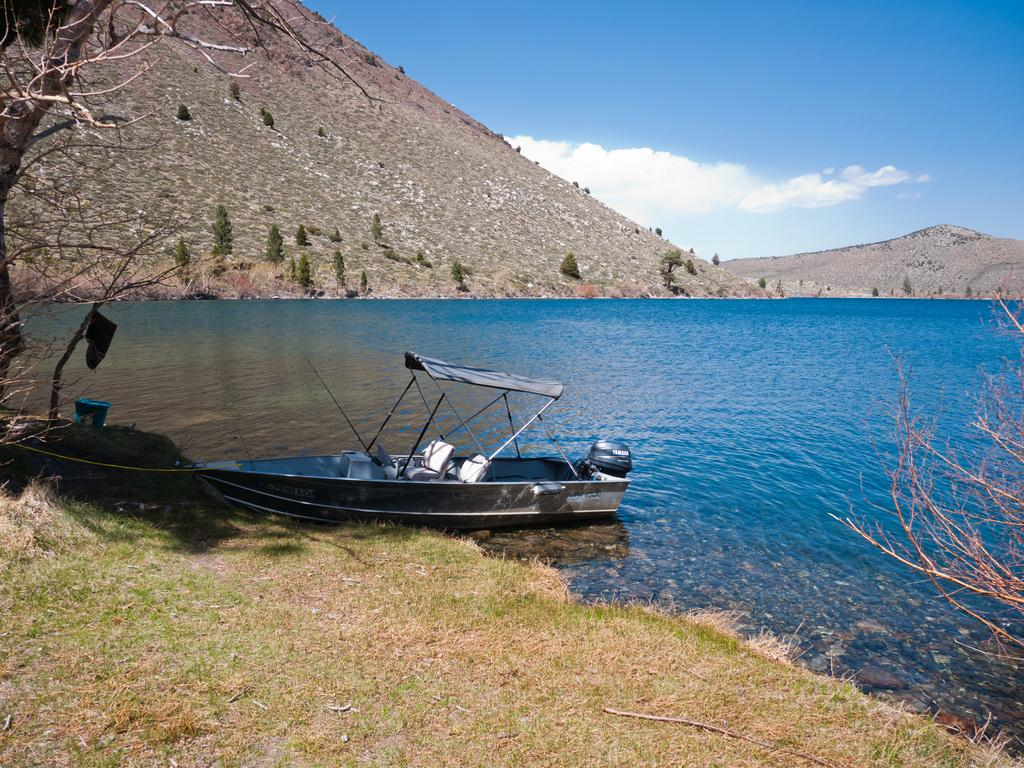What is the main feature in the center of the image? There is a river in the center of the image. What is on the river? There is a boat on the river. What type of vegetation is at the bottom of the image? Grass is present at the bottom of the image. What can be seen in the background of the image? There are trees, hills, and the sky visible in the background of the image. How many cacti are visible in the image? There are no cacti present in the image. What type of key is used to unlock the boat in the image? There is no key or boat-locking mechanism present in the image. 